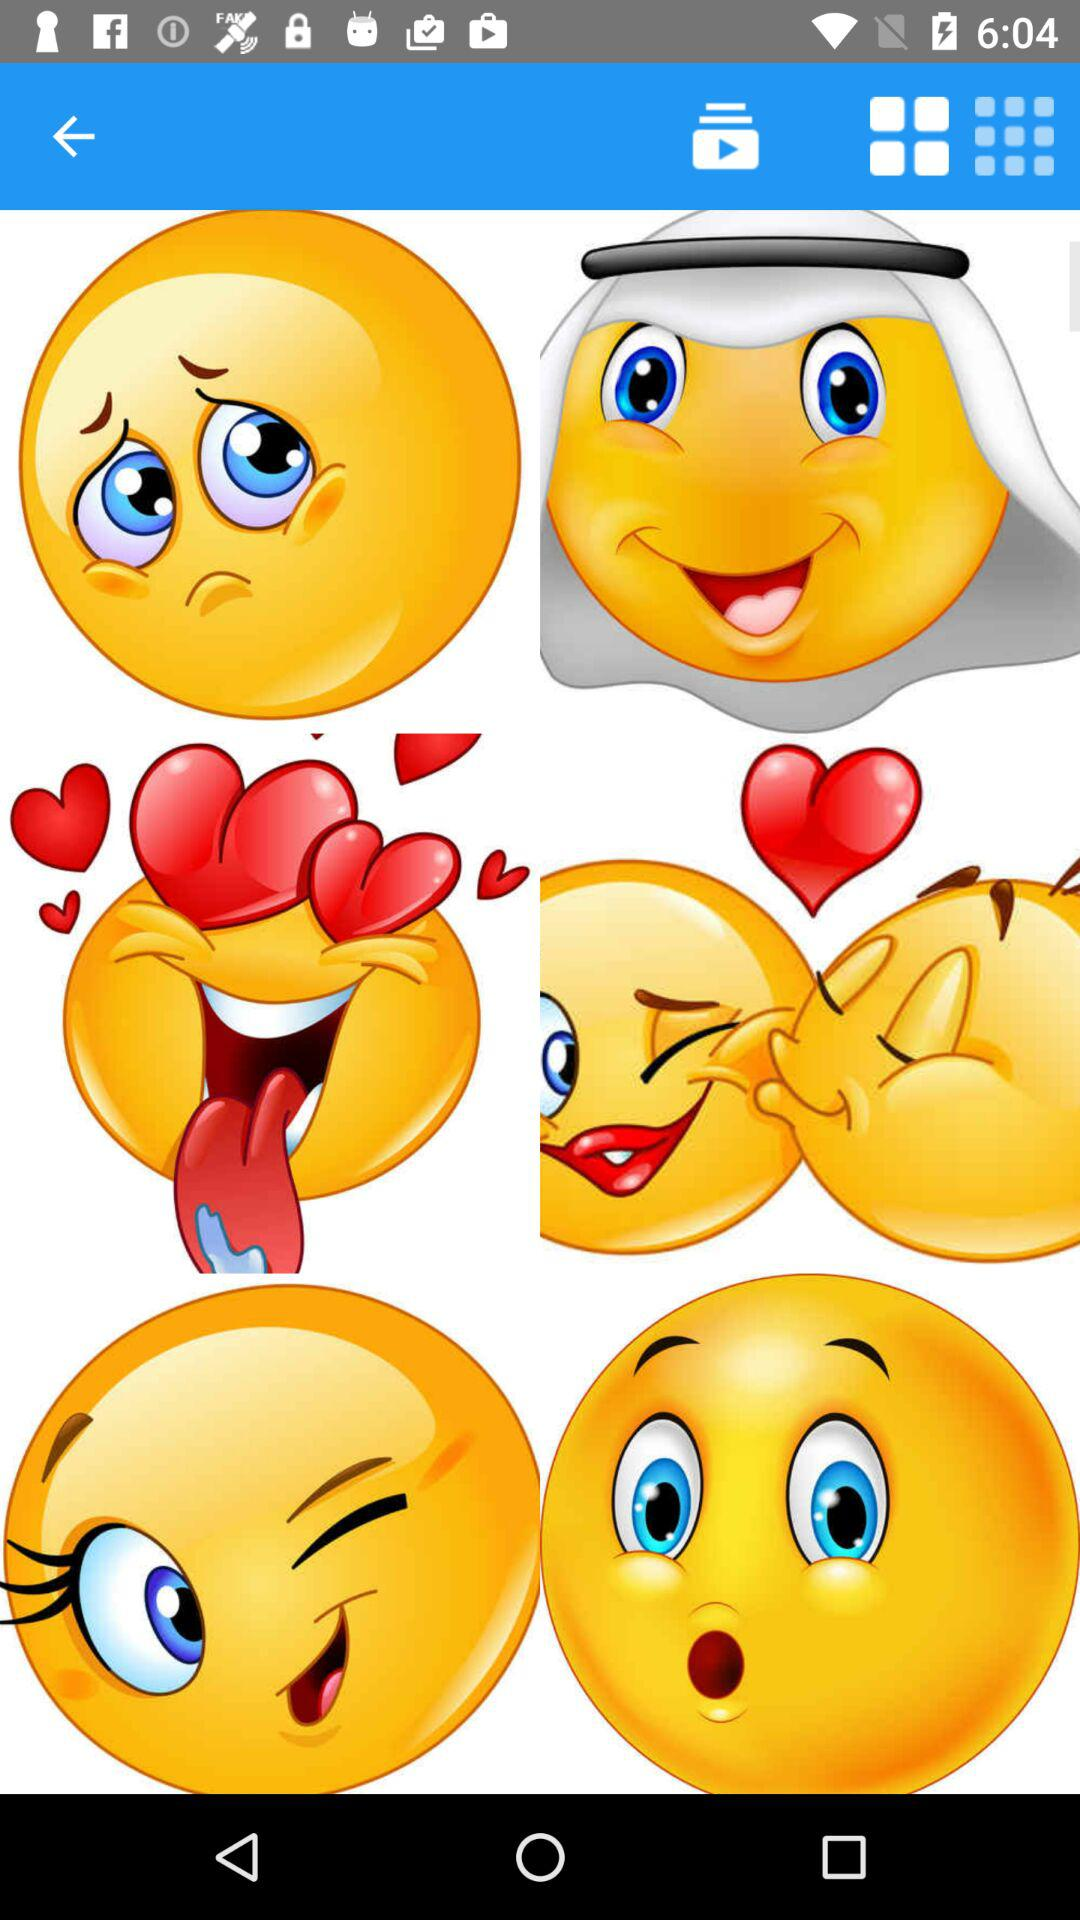How many more smiley faces are wearing a white scarf than are making a peace sign?
Answer the question using a single word or phrase. 1 